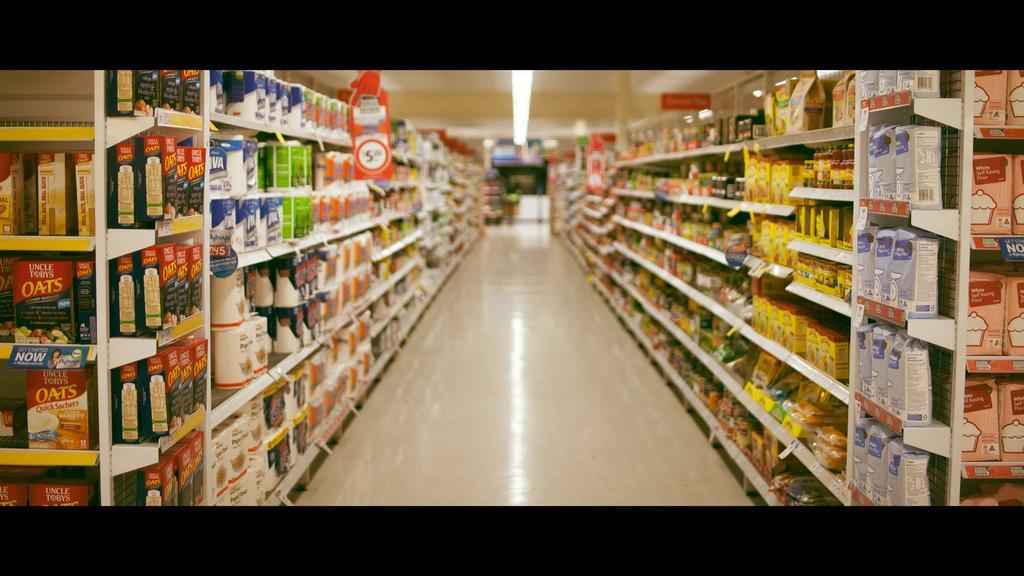Could you give a brief overview of what you see in this image? In this image I can see shelves. On these shelves I can see objects. Here I can see lights on the ceiling. 